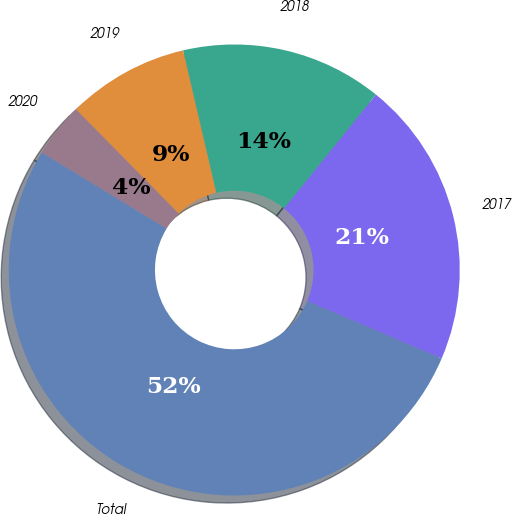Convert chart to OTSL. <chart><loc_0><loc_0><loc_500><loc_500><pie_chart><fcel>2017<fcel>2018<fcel>2019<fcel>2020<fcel>Total<nl><fcel>20.61%<fcel>14.46%<fcel>8.74%<fcel>3.9%<fcel>52.3%<nl></chart> 